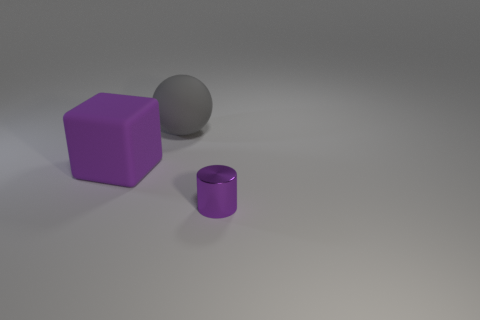Is the color of the matte block the same as the object to the right of the ball?
Keep it short and to the point. Yes. What number of things are things behind the tiny purple object or objects that are left of the purple metallic cylinder?
Offer a terse response. 2. How many other objects are there of the same material as the cylinder?
Your answer should be very brief. 0. There is a matte thing in front of the large matte thing on the right side of the large object that is in front of the big gray rubber sphere; what is its color?
Keep it short and to the point. Purple. What number of other things are there of the same color as the big sphere?
Offer a terse response. 0. Are there fewer green things than tiny purple cylinders?
Provide a short and direct response. Yes. The thing that is right of the large purple rubber cube and behind the shiny object is what color?
Ensure brevity in your answer.  Gray. Are there any other things that are the same size as the purple cylinder?
Ensure brevity in your answer.  No. Is the number of red matte balls greater than the number of purple cubes?
Ensure brevity in your answer.  No. What size is the object that is in front of the big gray rubber ball and on the right side of the big purple matte object?
Offer a very short reply. Small. 